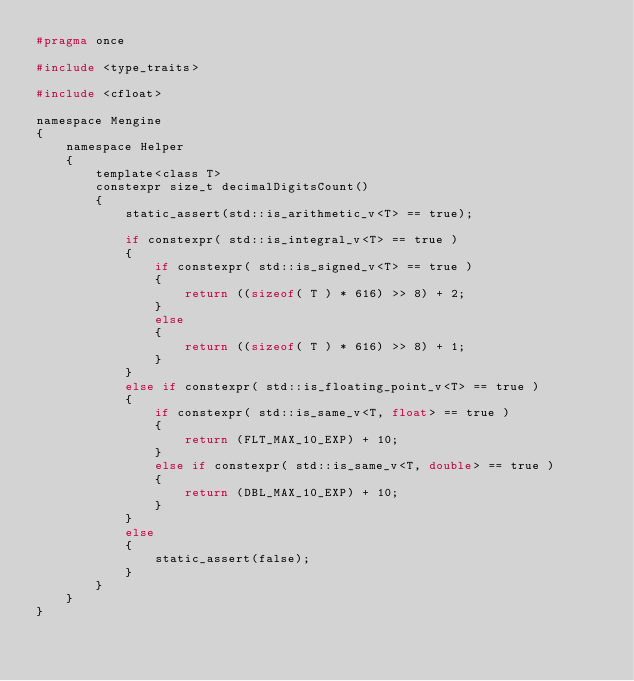<code> <loc_0><loc_0><loc_500><loc_500><_C_>#pragma once

#include <type_traits>

#include <cfloat>

namespace Mengine
{
    namespace Helper
    {
        template<class T>
        constexpr size_t decimalDigitsCount()
        {
            static_assert(std::is_arithmetic_v<T> == true);

            if constexpr( std::is_integral_v<T> == true )
            {
                if constexpr( std::is_signed_v<T> == true )
                {
                    return ((sizeof( T ) * 616) >> 8) + 2;
                }
                else
                {
                    return ((sizeof( T ) * 616) >> 8) + 1;
                }
            }
            else if constexpr( std::is_floating_point_v<T> == true )
            {
                if constexpr( std::is_same_v<T, float> == true )
                {
                    return (FLT_MAX_10_EXP) + 10;
                }
                else if constexpr( std::is_same_v<T, double> == true )
                {
                    return (DBL_MAX_10_EXP) + 10;
                }
            }
            else
            {
                static_assert(false);
            }
        }
    }
}</code> 